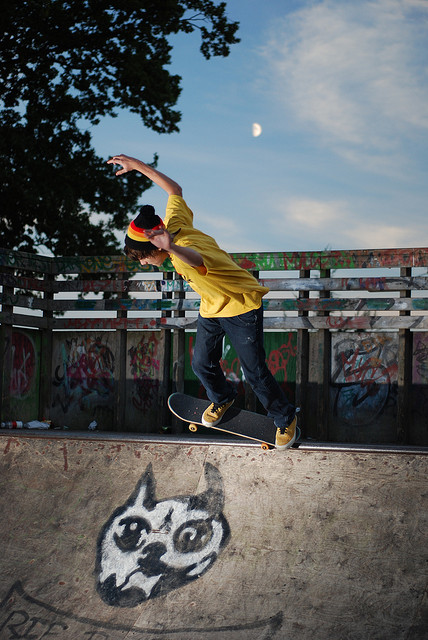Extract all visible text content from this image. RIP 